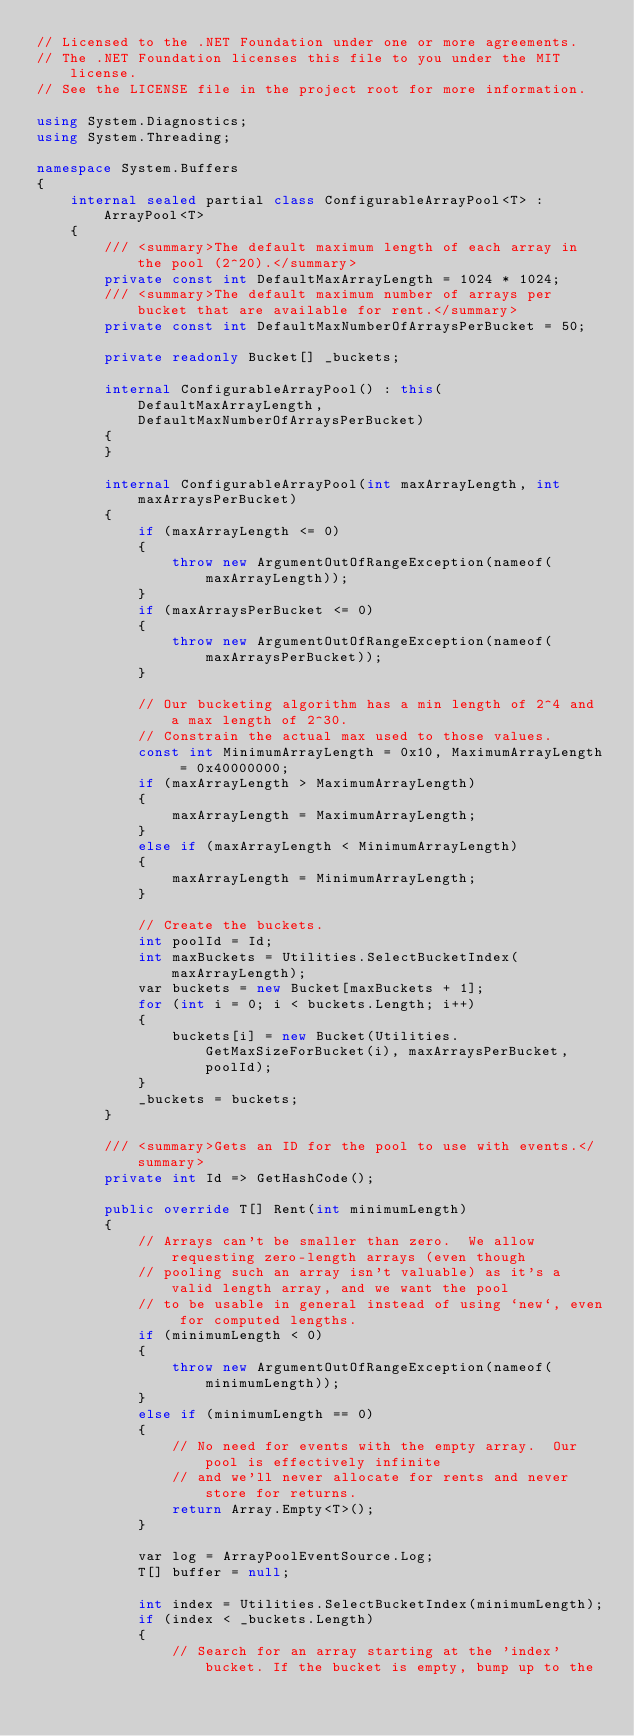<code> <loc_0><loc_0><loc_500><loc_500><_C#_>// Licensed to the .NET Foundation under one or more agreements.
// The .NET Foundation licenses this file to you under the MIT license.
// See the LICENSE file in the project root for more information.

using System.Diagnostics;
using System.Threading;

namespace System.Buffers
{
    internal sealed partial class ConfigurableArrayPool<T> : ArrayPool<T>
    {
        /// <summary>The default maximum length of each array in the pool (2^20).</summary>
        private const int DefaultMaxArrayLength = 1024 * 1024;
        /// <summary>The default maximum number of arrays per bucket that are available for rent.</summary>
        private const int DefaultMaxNumberOfArraysPerBucket = 50;

        private readonly Bucket[] _buckets;

        internal ConfigurableArrayPool() : this(DefaultMaxArrayLength, DefaultMaxNumberOfArraysPerBucket)
        {
        }

        internal ConfigurableArrayPool(int maxArrayLength, int maxArraysPerBucket)
        {
            if (maxArrayLength <= 0)
            {
                throw new ArgumentOutOfRangeException(nameof(maxArrayLength));
            }
            if (maxArraysPerBucket <= 0)
            {
                throw new ArgumentOutOfRangeException(nameof(maxArraysPerBucket));
            }

            // Our bucketing algorithm has a min length of 2^4 and a max length of 2^30.
            // Constrain the actual max used to those values.
            const int MinimumArrayLength = 0x10, MaximumArrayLength = 0x40000000;
            if (maxArrayLength > MaximumArrayLength)
            {
                maxArrayLength = MaximumArrayLength;
            }
            else if (maxArrayLength < MinimumArrayLength)
            {
                maxArrayLength = MinimumArrayLength;
            }

            // Create the buckets.
            int poolId = Id;
            int maxBuckets = Utilities.SelectBucketIndex(maxArrayLength);
            var buckets = new Bucket[maxBuckets + 1];
            for (int i = 0; i < buckets.Length; i++)
            {
                buckets[i] = new Bucket(Utilities.GetMaxSizeForBucket(i), maxArraysPerBucket, poolId);
            }
            _buckets = buckets;
        }

        /// <summary>Gets an ID for the pool to use with events.</summary>
        private int Id => GetHashCode();

        public override T[] Rent(int minimumLength)
        {
            // Arrays can't be smaller than zero.  We allow requesting zero-length arrays (even though
            // pooling such an array isn't valuable) as it's a valid length array, and we want the pool
            // to be usable in general instead of using `new`, even for computed lengths.
            if (minimumLength < 0)
            {
                throw new ArgumentOutOfRangeException(nameof(minimumLength));
            }
            else if (minimumLength == 0)
            {
                // No need for events with the empty array.  Our pool is effectively infinite
                // and we'll never allocate for rents and never store for returns.
                return Array.Empty<T>();
            }

            var log = ArrayPoolEventSource.Log;
            T[] buffer = null;

            int index = Utilities.SelectBucketIndex(minimumLength);
            if (index < _buckets.Length)
            {
                // Search for an array starting at the 'index' bucket. If the bucket is empty, bump up to the</code> 